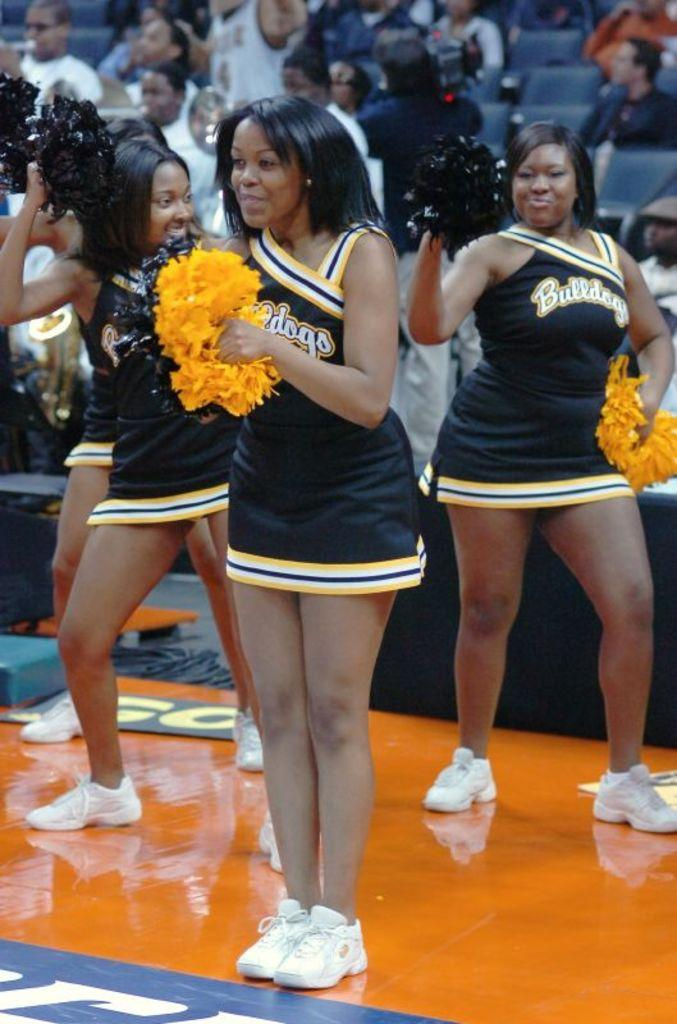<image>
Share a concise interpretation of the image provided. Cheerleaders wearing dresses that says "dogs" on it. 